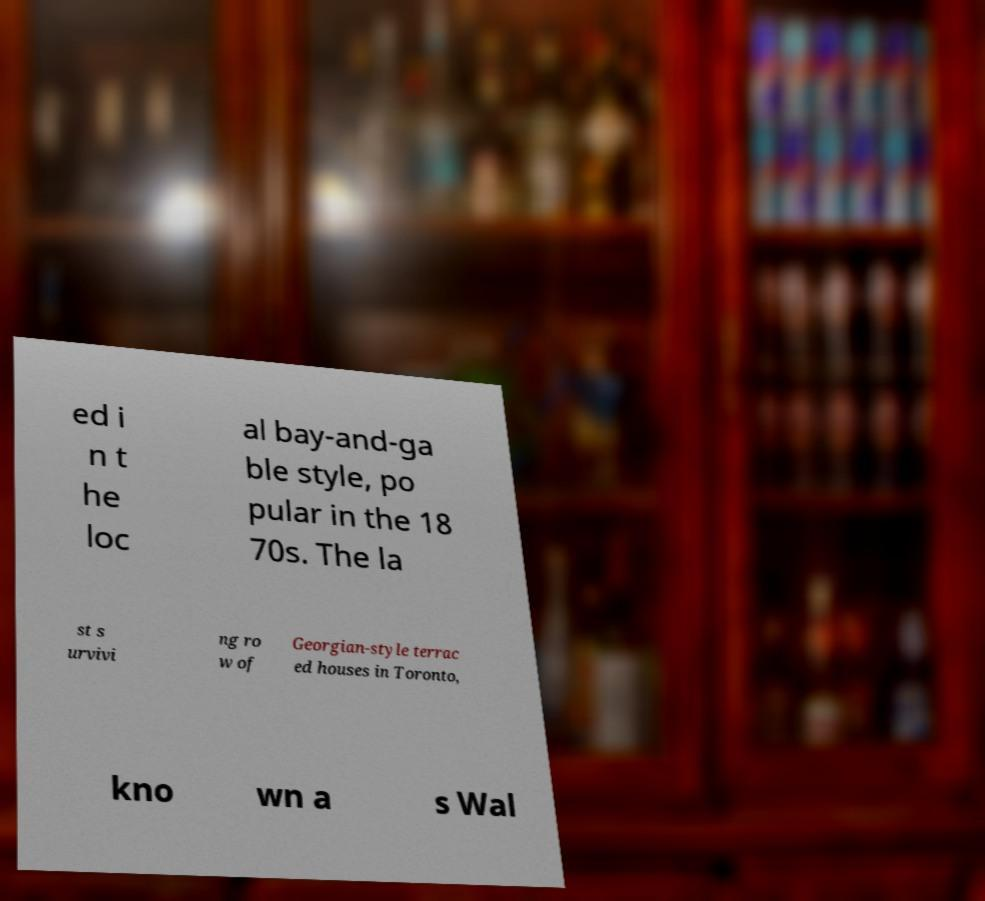Can you read and provide the text displayed in the image?This photo seems to have some interesting text. Can you extract and type it out for me? ed i n t he loc al bay-and-ga ble style, po pular in the 18 70s. The la st s urvivi ng ro w of Georgian-style terrac ed houses in Toronto, kno wn a s Wal 